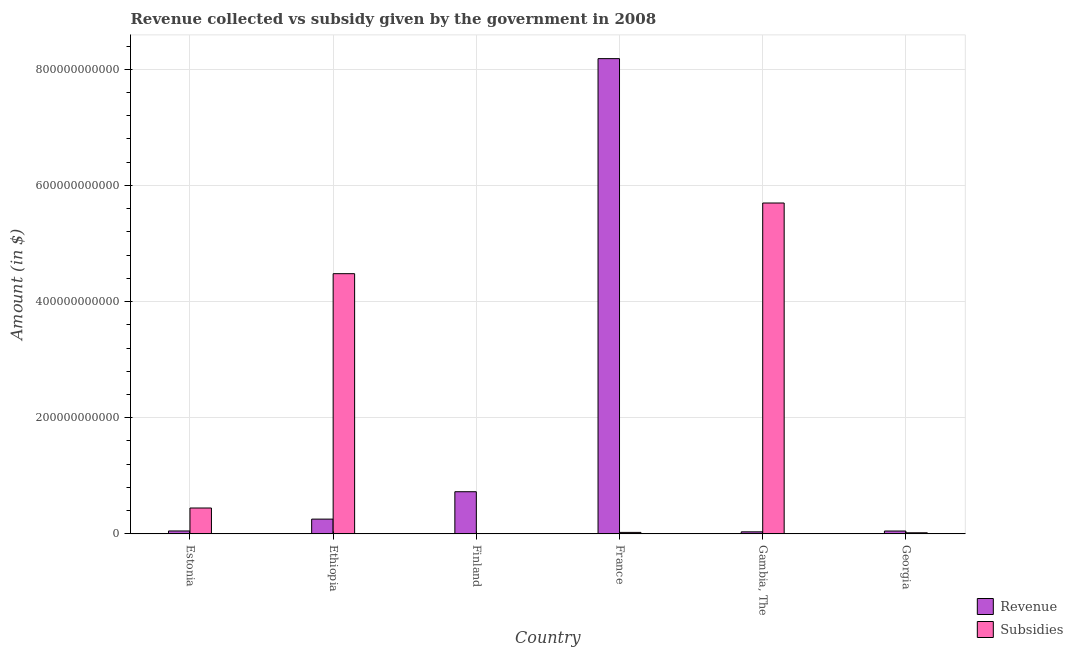How many different coloured bars are there?
Provide a short and direct response. 2. Are the number of bars per tick equal to the number of legend labels?
Make the answer very short. Yes. How many bars are there on the 2nd tick from the left?
Your answer should be compact. 2. What is the label of the 2nd group of bars from the left?
Your answer should be very brief. Ethiopia. In how many cases, is the number of bars for a given country not equal to the number of legend labels?
Offer a very short reply. 0. What is the amount of subsidies given in Finland?
Keep it short and to the point. 4.63e+08. Across all countries, what is the maximum amount of subsidies given?
Provide a short and direct response. 5.70e+11. Across all countries, what is the minimum amount of subsidies given?
Your response must be concise. 4.63e+08. In which country was the amount of subsidies given maximum?
Your response must be concise. Gambia, The. In which country was the amount of revenue collected minimum?
Offer a terse response. Gambia, The. What is the total amount of subsidies given in the graph?
Your answer should be compact. 1.07e+12. What is the difference between the amount of subsidies given in France and that in Georgia?
Provide a short and direct response. 6.36e+08. What is the difference between the amount of revenue collected in Finland and the amount of subsidies given in Ethiopia?
Give a very brief answer. -3.75e+11. What is the average amount of subsidies given per country?
Provide a succinct answer. 1.78e+11. What is the difference between the amount of revenue collected and amount of subsidies given in Estonia?
Keep it short and to the point. -3.95e+1. In how many countries, is the amount of revenue collected greater than 480000000000 $?
Give a very brief answer. 1. What is the ratio of the amount of subsidies given in Ethiopia to that in Finland?
Offer a very short reply. 967.18. Is the difference between the amount of subsidies given in Finland and Georgia greater than the difference between the amount of revenue collected in Finland and Georgia?
Provide a short and direct response. No. What is the difference between the highest and the second highest amount of revenue collected?
Ensure brevity in your answer.  7.46e+11. What is the difference between the highest and the lowest amount of revenue collected?
Your answer should be compact. 8.15e+11. In how many countries, is the amount of subsidies given greater than the average amount of subsidies given taken over all countries?
Your answer should be very brief. 2. What does the 2nd bar from the left in Estonia represents?
Your response must be concise. Subsidies. What does the 2nd bar from the right in Finland represents?
Your answer should be very brief. Revenue. How many bars are there?
Provide a short and direct response. 12. What is the difference between two consecutive major ticks on the Y-axis?
Your answer should be compact. 2.00e+11. Are the values on the major ticks of Y-axis written in scientific E-notation?
Make the answer very short. No. Does the graph contain any zero values?
Provide a short and direct response. No. How many legend labels are there?
Offer a terse response. 2. How are the legend labels stacked?
Keep it short and to the point. Vertical. What is the title of the graph?
Provide a short and direct response. Revenue collected vs subsidy given by the government in 2008. Does "Nonresident" appear as one of the legend labels in the graph?
Make the answer very short. No. What is the label or title of the Y-axis?
Offer a very short reply. Amount (in $). What is the Amount (in $) in Revenue in Estonia?
Offer a terse response. 4.98e+09. What is the Amount (in $) in Subsidies in Estonia?
Give a very brief answer. 4.45e+1. What is the Amount (in $) of Revenue in Ethiopia?
Provide a succinct answer. 2.54e+1. What is the Amount (in $) in Subsidies in Ethiopia?
Give a very brief answer. 4.48e+11. What is the Amount (in $) in Revenue in Finland?
Provide a succinct answer. 7.26e+1. What is the Amount (in $) of Subsidies in Finland?
Give a very brief answer. 4.63e+08. What is the Amount (in $) of Revenue in France?
Your answer should be very brief. 8.18e+11. What is the Amount (in $) in Subsidies in France?
Keep it short and to the point. 2.51e+09. What is the Amount (in $) of Revenue in Gambia, The?
Ensure brevity in your answer.  3.50e+09. What is the Amount (in $) in Subsidies in Gambia, The?
Your response must be concise. 5.70e+11. What is the Amount (in $) of Revenue in Georgia?
Your response must be concise. 4.90e+09. What is the Amount (in $) of Subsidies in Georgia?
Your answer should be very brief. 1.87e+09. Across all countries, what is the maximum Amount (in $) of Revenue?
Your response must be concise. 8.18e+11. Across all countries, what is the maximum Amount (in $) in Subsidies?
Your answer should be very brief. 5.70e+11. Across all countries, what is the minimum Amount (in $) of Revenue?
Offer a very short reply. 3.50e+09. Across all countries, what is the minimum Amount (in $) of Subsidies?
Your answer should be compact. 4.63e+08. What is the total Amount (in $) in Revenue in the graph?
Offer a very short reply. 9.30e+11. What is the total Amount (in $) of Subsidies in the graph?
Offer a terse response. 1.07e+12. What is the difference between the Amount (in $) in Revenue in Estonia and that in Ethiopia?
Your response must be concise. -2.04e+1. What is the difference between the Amount (in $) in Subsidies in Estonia and that in Ethiopia?
Give a very brief answer. -4.03e+11. What is the difference between the Amount (in $) in Revenue in Estonia and that in Finland?
Keep it short and to the point. -6.76e+1. What is the difference between the Amount (in $) in Subsidies in Estonia and that in Finland?
Provide a short and direct response. 4.41e+1. What is the difference between the Amount (in $) in Revenue in Estonia and that in France?
Give a very brief answer. -8.13e+11. What is the difference between the Amount (in $) in Subsidies in Estonia and that in France?
Your response must be concise. 4.20e+1. What is the difference between the Amount (in $) of Revenue in Estonia and that in Gambia, The?
Your answer should be compact. 1.48e+09. What is the difference between the Amount (in $) in Subsidies in Estonia and that in Gambia, The?
Keep it short and to the point. -5.25e+11. What is the difference between the Amount (in $) in Revenue in Estonia and that in Georgia?
Your answer should be very brief. 8.42e+07. What is the difference between the Amount (in $) in Subsidies in Estonia and that in Georgia?
Keep it short and to the point. 4.26e+1. What is the difference between the Amount (in $) in Revenue in Ethiopia and that in Finland?
Provide a short and direct response. -4.72e+1. What is the difference between the Amount (in $) of Subsidies in Ethiopia and that in Finland?
Offer a very short reply. 4.48e+11. What is the difference between the Amount (in $) in Revenue in Ethiopia and that in France?
Keep it short and to the point. -7.93e+11. What is the difference between the Amount (in $) in Subsidies in Ethiopia and that in France?
Keep it short and to the point. 4.45e+11. What is the difference between the Amount (in $) in Revenue in Ethiopia and that in Gambia, The?
Offer a terse response. 2.19e+1. What is the difference between the Amount (in $) in Subsidies in Ethiopia and that in Gambia, The?
Your answer should be compact. -1.22e+11. What is the difference between the Amount (in $) of Revenue in Ethiopia and that in Georgia?
Your response must be concise. 2.05e+1. What is the difference between the Amount (in $) in Subsidies in Ethiopia and that in Georgia?
Ensure brevity in your answer.  4.46e+11. What is the difference between the Amount (in $) of Revenue in Finland and that in France?
Make the answer very short. -7.46e+11. What is the difference between the Amount (in $) in Subsidies in Finland and that in France?
Keep it short and to the point. -2.04e+09. What is the difference between the Amount (in $) in Revenue in Finland and that in Gambia, The?
Make the answer very short. 6.91e+1. What is the difference between the Amount (in $) in Subsidies in Finland and that in Gambia, The?
Provide a succinct answer. -5.69e+11. What is the difference between the Amount (in $) in Revenue in Finland and that in Georgia?
Make the answer very short. 6.77e+1. What is the difference between the Amount (in $) of Subsidies in Finland and that in Georgia?
Your answer should be compact. -1.41e+09. What is the difference between the Amount (in $) in Revenue in France and that in Gambia, The?
Offer a very short reply. 8.15e+11. What is the difference between the Amount (in $) of Subsidies in France and that in Gambia, The?
Offer a terse response. -5.67e+11. What is the difference between the Amount (in $) in Revenue in France and that in Georgia?
Keep it short and to the point. 8.13e+11. What is the difference between the Amount (in $) in Subsidies in France and that in Georgia?
Your answer should be very brief. 6.36e+08. What is the difference between the Amount (in $) of Revenue in Gambia, The and that in Georgia?
Give a very brief answer. -1.40e+09. What is the difference between the Amount (in $) in Subsidies in Gambia, The and that in Georgia?
Your response must be concise. 5.68e+11. What is the difference between the Amount (in $) in Revenue in Estonia and the Amount (in $) in Subsidies in Ethiopia?
Your answer should be very brief. -4.43e+11. What is the difference between the Amount (in $) in Revenue in Estonia and the Amount (in $) in Subsidies in Finland?
Keep it short and to the point. 4.52e+09. What is the difference between the Amount (in $) of Revenue in Estonia and the Amount (in $) of Subsidies in France?
Offer a very short reply. 2.48e+09. What is the difference between the Amount (in $) in Revenue in Estonia and the Amount (in $) in Subsidies in Gambia, The?
Provide a succinct answer. -5.65e+11. What is the difference between the Amount (in $) in Revenue in Estonia and the Amount (in $) in Subsidies in Georgia?
Keep it short and to the point. 3.11e+09. What is the difference between the Amount (in $) of Revenue in Ethiopia and the Amount (in $) of Subsidies in Finland?
Offer a terse response. 2.49e+1. What is the difference between the Amount (in $) of Revenue in Ethiopia and the Amount (in $) of Subsidies in France?
Ensure brevity in your answer.  2.29e+1. What is the difference between the Amount (in $) of Revenue in Ethiopia and the Amount (in $) of Subsidies in Gambia, The?
Give a very brief answer. -5.44e+11. What is the difference between the Amount (in $) of Revenue in Ethiopia and the Amount (in $) of Subsidies in Georgia?
Provide a short and direct response. 2.35e+1. What is the difference between the Amount (in $) of Revenue in Finland and the Amount (in $) of Subsidies in France?
Offer a terse response. 7.00e+1. What is the difference between the Amount (in $) of Revenue in Finland and the Amount (in $) of Subsidies in Gambia, The?
Ensure brevity in your answer.  -4.97e+11. What is the difference between the Amount (in $) of Revenue in Finland and the Amount (in $) of Subsidies in Georgia?
Provide a short and direct response. 7.07e+1. What is the difference between the Amount (in $) of Revenue in France and the Amount (in $) of Subsidies in Gambia, The?
Offer a terse response. 2.49e+11. What is the difference between the Amount (in $) of Revenue in France and the Amount (in $) of Subsidies in Georgia?
Your response must be concise. 8.16e+11. What is the difference between the Amount (in $) in Revenue in Gambia, The and the Amount (in $) in Subsidies in Georgia?
Your answer should be very brief. 1.63e+09. What is the average Amount (in $) of Revenue per country?
Give a very brief answer. 1.55e+11. What is the average Amount (in $) in Subsidies per country?
Make the answer very short. 1.78e+11. What is the difference between the Amount (in $) of Revenue and Amount (in $) of Subsidies in Estonia?
Offer a terse response. -3.95e+1. What is the difference between the Amount (in $) of Revenue and Amount (in $) of Subsidies in Ethiopia?
Keep it short and to the point. -4.23e+11. What is the difference between the Amount (in $) in Revenue and Amount (in $) in Subsidies in Finland?
Provide a succinct answer. 7.21e+1. What is the difference between the Amount (in $) in Revenue and Amount (in $) in Subsidies in France?
Give a very brief answer. 8.16e+11. What is the difference between the Amount (in $) of Revenue and Amount (in $) of Subsidies in Gambia, The?
Provide a succinct answer. -5.66e+11. What is the difference between the Amount (in $) in Revenue and Amount (in $) in Subsidies in Georgia?
Ensure brevity in your answer.  3.03e+09. What is the ratio of the Amount (in $) in Revenue in Estonia to that in Ethiopia?
Keep it short and to the point. 0.2. What is the ratio of the Amount (in $) of Subsidies in Estonia to that in Ethiopia?
Provide a short and direct response. 0.1. What is the ratio of the Amount (in $) of Revenue in Estonia to that in Finland?
Offer a terse response. 0.07. What is the ratio of the Amount (in $) in Subsidies in Estonia to that in Finland?
Your answer should be compact. 96.12. What is the ratio of the Amount (in $) in Revenue in Estonia to that in France?
Offer a terse response. 0.01. What is the ratio of the Amount (in $) in Subsidies in Estonia to that in France?
Give a very brief answer. 17.76. What is the ratio of the Amount (in $) of Revenue in Estonia to that in Gambia, The?
Provide a short and direct response. 1.42. What is the ratio of the Amount (in $) of Subsidies in Estonia to that in Gambia, The?
Make the answer very short. 0.08. What is the ratio of the Amount (in $) in Revenue in Estonia to that in Georgia?
Give a very brief answer. 1.02. What is the ratio of the Amount (in $) in Subsidies in Estonia to that in Georgia?
Provide a succinct answer. 23.79. What is the ratio of the Amount (in $) in Revenue in Ethiopia to that in Finland?
Ensure brevity in your answer.  0.35. What is the ratio of the Amount (in $) in Subsidies in Ethiopia to that in Finland?
Your answer should be very brief. 967.18. What is the ratio of the Amount (in $) in Revenue in Ethiopia to that in France?
Your response must be concise. 0.03. What is the ratio of the Amount (in $) in Subsidies in Ethiopia to that in France?
Your answer should be compact. 178.66. What is the ratio of the Amount (in $) of Revenue in Ethiopia to that in Gambia, The?
Your answer should be compact. 7.25. What is the ratio of the Amount (in $) of Subsidies in Ethiopia to that in Gambia, The?
Provide a succinct answer. 0.79. What is the ratio of the Amount (in $) of Revenue in Ethiopia to that in Georgia?
Give a very brief answer. 5.18. What is the ratio of the Amount (in $) of Subsidies in Ethiopia to that in Georgia?
Give a very brief answer. 239.37. What is the ratio of the Amount (in $) in Revenue in Finland to that in France?
Your response must be concise. 0.09. What is the ratio of the Amount (in $) in Subsidies in Finland to that in France?
Keep it short and to the point. 0.18. What is the ratio of the Amount (in $) of Revenue in Finland to that in Gambia, The?
Make the answer very short. 20.73. What is the ratio of the Amount (in $) of Subsidies in Finland to that in Gambia, The?
Your response must be concise. 0. What is the ratio of the Amount (in $) in Revenue in Finland to that in Georgia?
Provide a succinct answer. 14.8. What is the ratio of the Amount (in $) in Subsidies in Finland to that in Georgia?
Your answer should be compact. 0.25. What is the ratio of the Amount (in $) of Revenue in France to that in Gambia, The?
Provide a short and direct response. 233.79. What is the ratio of the Amount (in $) of Subsidies in France to that in Gambia, The?
Ensure brevity in your answer.  0. What is the ratio of the Amount (in $) of Revenue in France to that in Georgia?
Keep it short and to the point. 166.97. What is the ratio of the Amount (in $) in Subsidies in France to that in Georgia?
Your response must be concise. 1.34. What is the ratio of the Amount (in $) in Revenue in Gambia, The to that in Georgia?
Offer a very short reply. 0.71. What is the ratio of the Amount (in $) in Subsidies in Gambia, The to that in Georgia?
Give a very brief answer. 304.38. What is the difference between the highest and the second highest Amount (in $) of Revenue?
Make the answer very short. 7.46e+11. What is the difference between the highest and the second highest Amount (in $) in Subsidies?
Provide a short and direct response. 1.22e+11. What is the difference between the highest and the lowest Amount (in $) of Revenue?
Give a very brief answer. 8.15e+11. What is the difference between the highest and the lowest Amount (in $) of Subsidies?
Your answer should be compact. 5.69e+11. 